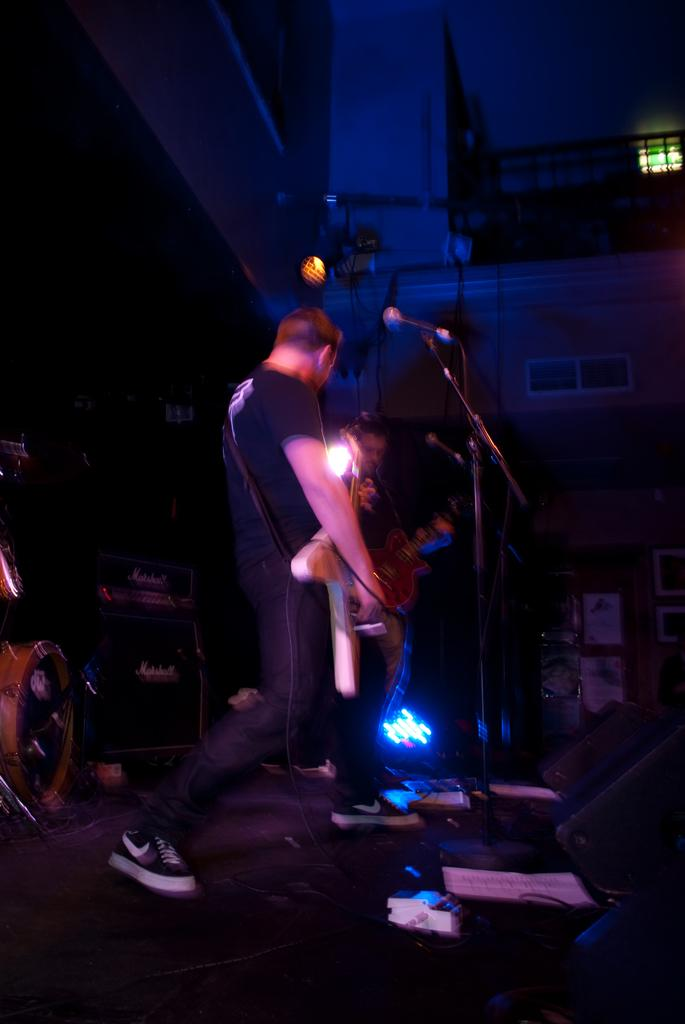Who is the main subject in the image? There is a man in the image. What is the man doing in the image? The man is playing a guitar. What object is in front of the man? There is a microphone in front of the man. Where is the man located in the image? The man is on a stage. What type of profit is the man generating from the bomb in the image? There is no bomb present in the image, and therefore no profit can be generated from it. 